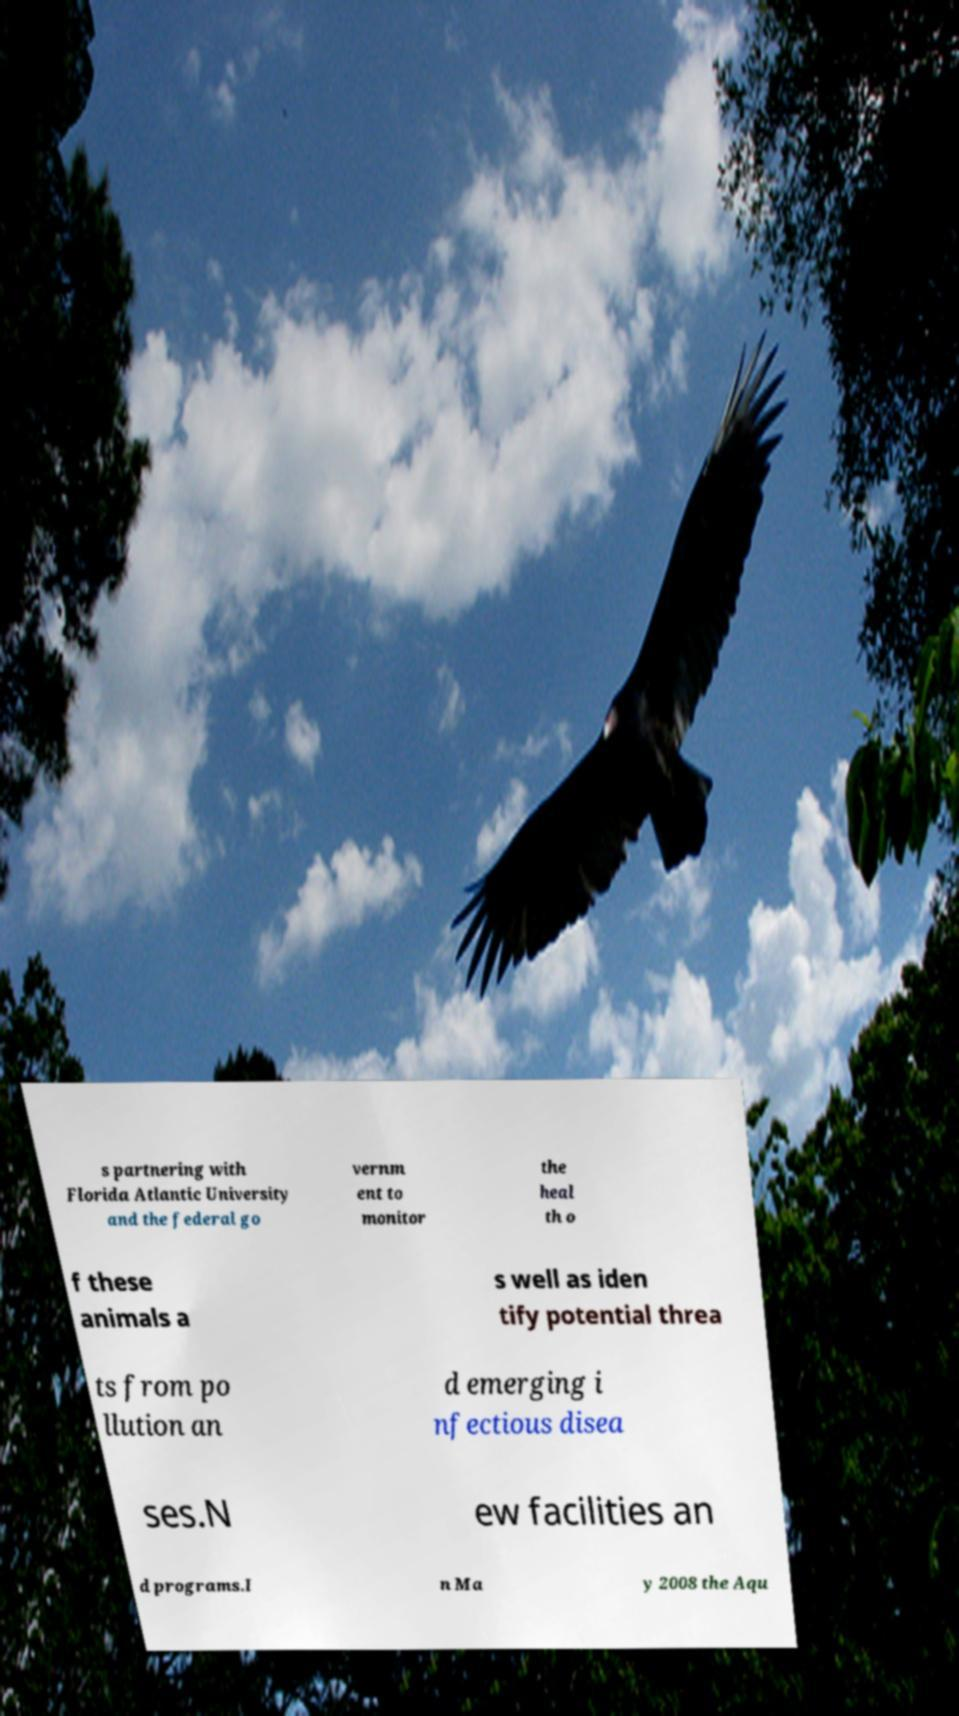Can you accurately transcribe the text from the provided image for me? s partnering with Florida Atlantic University and the federal go vernm ent to monitor the heal th o f these animals a s well as iden tify potential threa ts from po llution an d emerging i nfectious disea ses.N ew facilities an d programs.I n Ma y 2008 the Aqu 